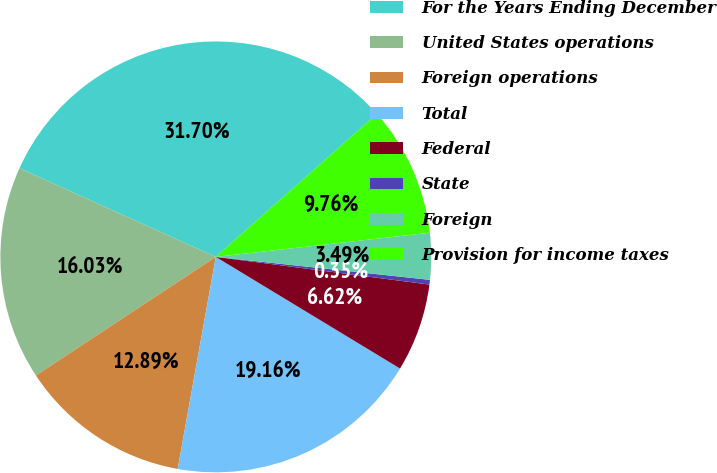Convert chart to OTSL. <chart><loc_0><loc_0><loc_500><loc_500><pie_chart><fcel>For the Years Ending December<fcel>United States operations<fcel>Foreign operations<fcel>Total<fcel>Federal<fcel>State<fcel>Foreign<fcel>Provision for income taxes<nl><fcel>31.7%<fcel>16.03%<fcel>12.89%<fcel>19.16%<fcel>6.62%<fcel>0.35%<fcel>3.49%<fcel>9.76%<nl></chart> 